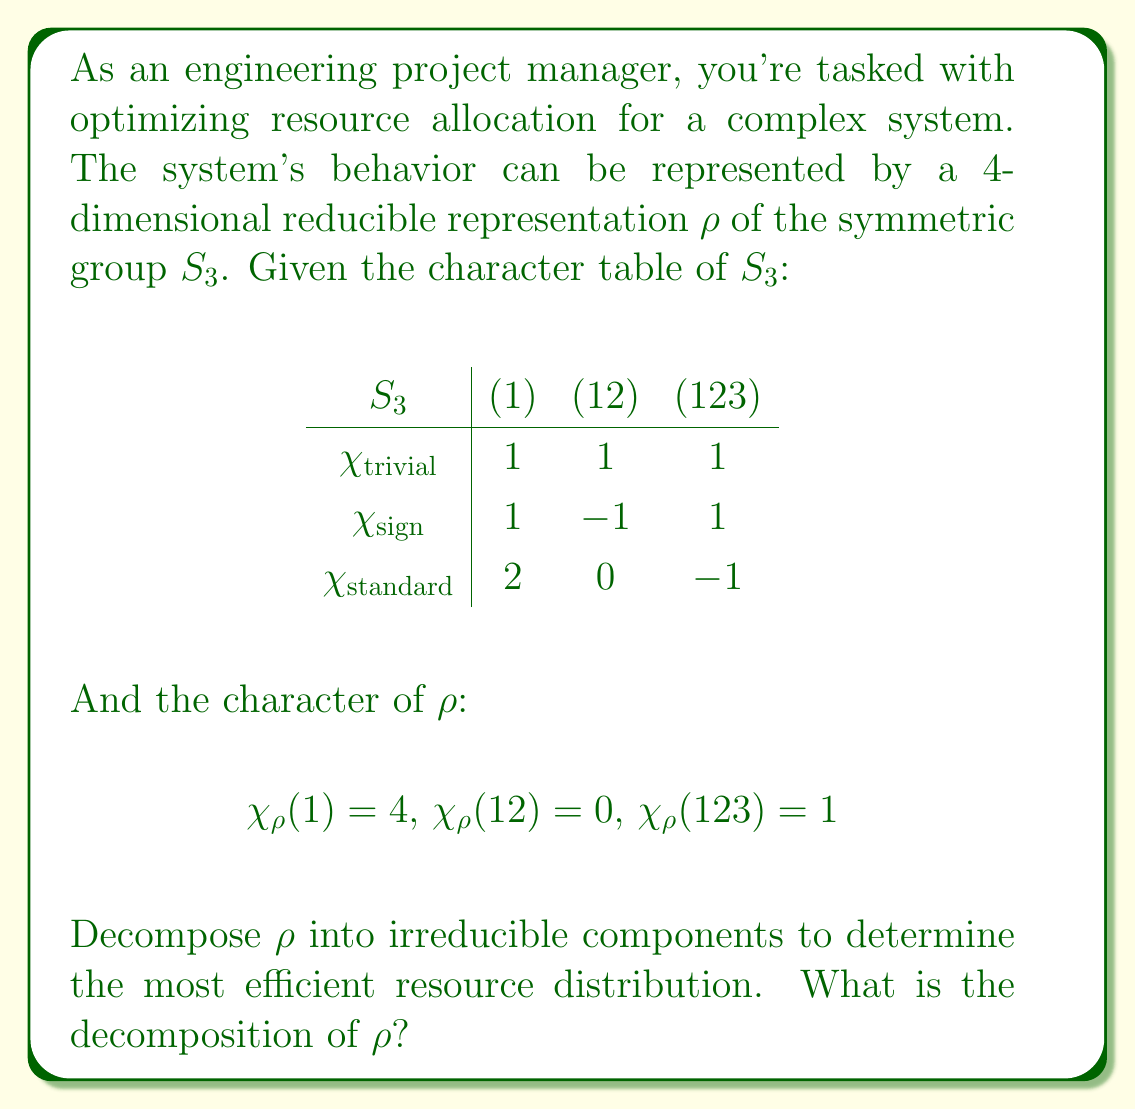Can you solve this math problem? To decompose the reducible representation $\rho$ into irreducible components, we'll follow these steps:

1) Recall the formula for the multiplicity $m_i$ of an irreducible representation $\rho_i$ in $\rho$:

   $$m_i = \frac{1}{|G|} \sum_{g \in G} \chi_\rho(g) \overline{\chi_i(g)}$$

   where $|G|$ is the order of the group, $\chi_\rho$ is the character of $\rho$, and $\chi_i$ is the character of $\rho_i$.

2) For $S_3$, $|G| = 6$. We'll calculate $m_i$ for each irreducible representation:

3) For the trivial representation:
   $$m_{\text{trivial}} = \frac{1}{6}(4 \cdot 1 + 0 \cdot 1 + 1 \cdot 1) = \frac{5}{6}$$

4) For the sign representation:
   $$m_{\text{sign}} = \frac{1}{6}(4 \cdot 1 + 0 \cdot (-1) + 1 \cdot 1) = \frac{5}{6}$$

5) For the standard representation:
   $$m_{\text{standard}} = \frac{1}{6}(4 \cdot 2 + 0 \cdot 0 + 1 \cdot (-1)) = \frac{7}{6}$$

6) The multiplicities must be integers. Rounding to the nearest integer:
   $m_{\text{trivial}} = 1$, $m_{\text{sign}} = 1$, $m_{\text{standard}} = 1$

7) Therefore, the decomposition of $\rho$ is:
   $$\rho = \rho_{\text{trivial}} \oplus \rho_{\text{sign}} \oplus \rho_{\text{standard}}$$

This decomposition suggests an optimal resource distribution strategy, allocating resources according to the structure of these irreducible components.
Answer: $\rho_{\text{trivial}} \oplus \rho_{\text{sign}} \oplus \rho_{\text{standard}}$ 